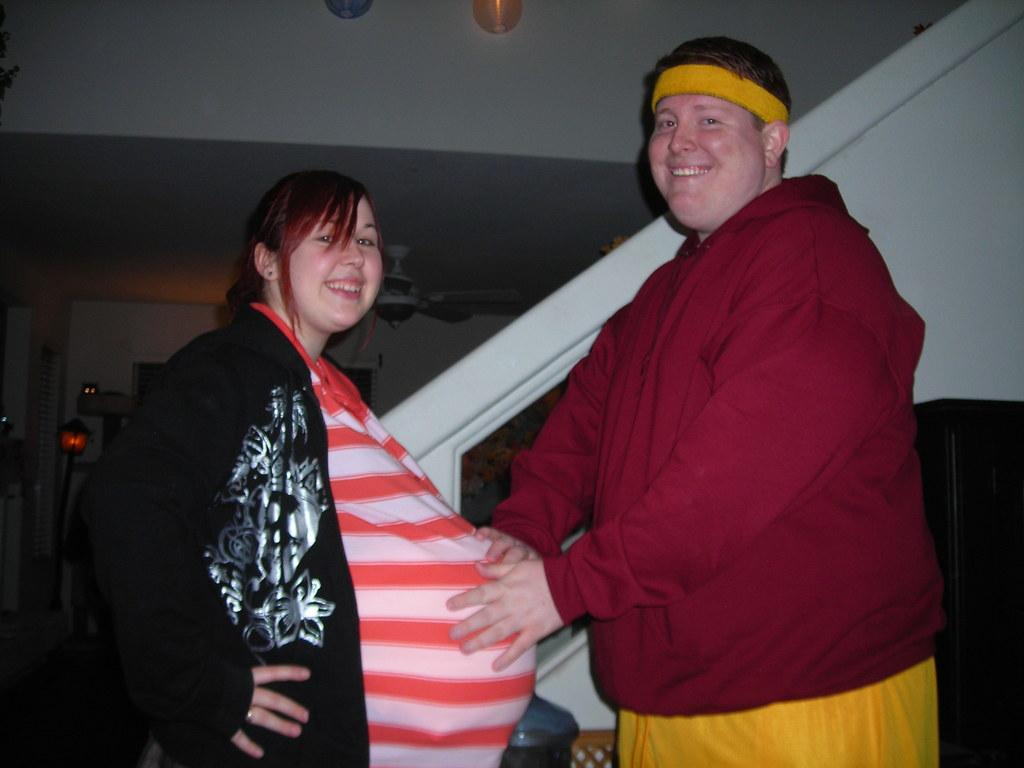Who are the people in the center of the picture? There is a woman and a man in the center of the picture. What are the expressions on their faces? The woman and the man are smiling. Where was the picture taken? The picture was taken in a house. What can be seen in the background of the image? There is a staircase, a couch, and a bubble in the background of the image, along with other objects. What time is shown on the map in the background of the image? There is no map present in the image, so it is not possible to determine the time shown on it. 